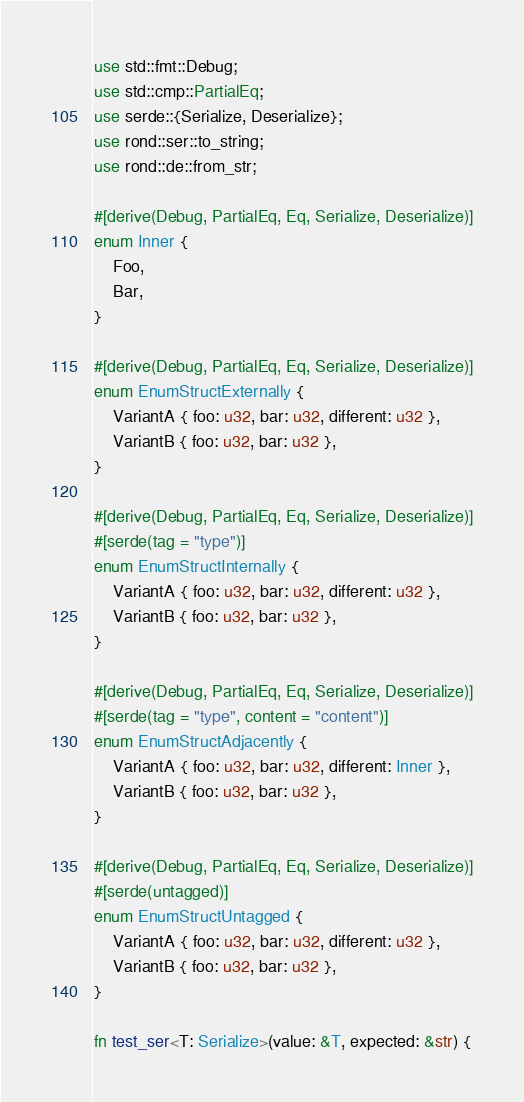Convert code to text. <code><loc_0><loc_0><loc_500><loc_500><_Rust_>use std::fmt::Debug;
use std::cmp::PartialEq;
use serde::{Serialize, Deserialize};
use rond::ser::to_string;
use rond::de::from_str;

#[derive(Debug, PartialEq, Eq, Serialize, Deserialize)]
enum Inner {
    Foo,
    Bar,
}

#[derive(Debug, PartialEq, Eq, Serialize, Deserialize)]
enum EnumStructExternally {
    VariantA { foo: u32, bar: u32, different: u32 },
    VariantB { foo: u32, bar: u32 },
}

#[derive(Debug, PartialEq, Eq, Serialize, Deserialize)]
#[serde(tag = "type")]
enum EnumStructInternally {
    VariantA { foo: u32, bar: u32, different: u32 },
    VariantB { foo: u32, bar: u32 },
}

#[derive(Debug, PartialEq, Eq, Serialize, Deserialize)]
#[serde(tag = "type", content = "content")]
enum EnumStructAdjacently {
    VariantA { foo: u32, bar: u32, different: Inner },
    VariantB { foo: u32, bar: u32 },
}

#[derive(Debug, PartialEq, Eq, Serialize, Deserialize)]
#[serde(untagged)]
enum EnumStructUntagged {
    VariantA { foo: u32, bar: u32, different: u32 },
    VariantB { foo: u32, bar: u32 },
}

fn test_ser<T: Serialize>(value: &T, expected: &str) {</code> 